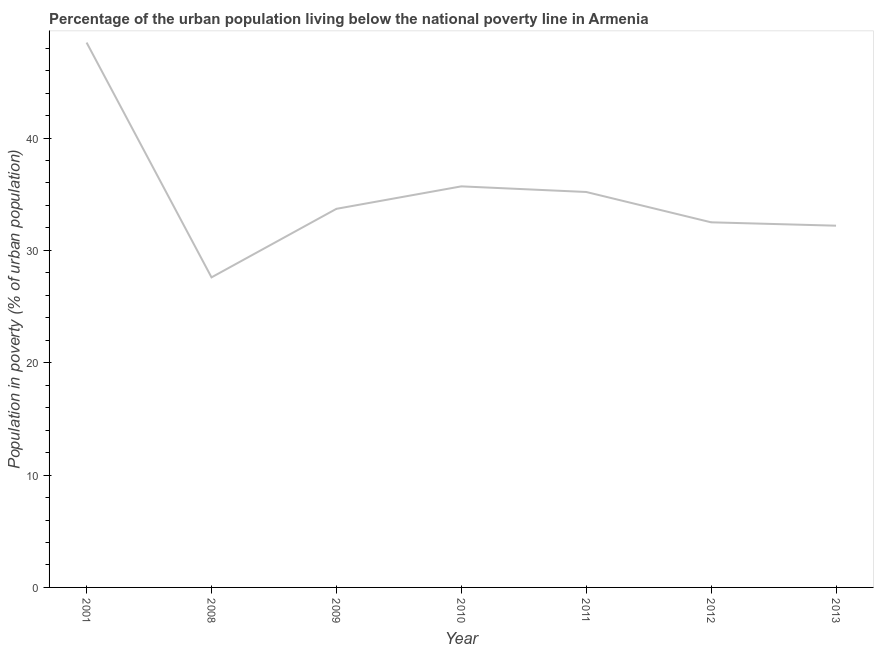What is the percentage of urban population living below poverty line in 2001?
Ensure brevity in your answer.  48.5. Across all years, what is the maximum percentage of urban population living below poverty line?
Keep it short and to the point. 48.5. Across all years, what is the minimum percentage of urban population living below poverty line?
Ensure brevity in your answer.  27.6. In which year was the percentage of urban population living below poverty line maximum?
Provide a succinct answer. 2001. In which year was the percentage of urban population living below poverty line minimum?
Offer a terse response. 2008. What is the sum of the percentage of urban population living below poverty line?
Provide a short and direct response. 245.4. What is the difference between the percentage of urban population living below poverty line in 2008 and 2009?
Give a very brief answer. -6.1. What is the average percentage of urban population living below poverty line per year?
Ensure brevity in your answer.  35.06. What is the median percentage of urban population living below poverty line?
Keep it short and to the point. 33.7. In how many years, is the percentage of urban population living below poverty line greater than 10 %?
Offer a very short reply. 7. Do a majority of the years between 2010 and 2011 (inclusive) have percentage of urban population living below poverty line greater than 6 %?
Your answer should be compact. Yes. What is the ratio of the percentage of urban population living below poverty line in 2010 to that in 2011?
Your response must be concise. 1.01. Is the percentage of urban population living below poverty line in 2011 less than that in 2013?
Make the answer very short. No. Is the difference between the percentage of urban population living below poverty line in 2009 and 2011 greater than the difference between any two years?
Your answer should be very brief. No. What is the difference between the highest and the second highest percentage of urban population living below poverty line?
Ensure brevity in your answer.  12.8. Is the sum of the percentage of urban population living below poverty line in 2008 and 2013 greater than the maximum percentage of urban population living below poverty line across all years?
Provide a short and direct response. Yes. What is the difference between the highest and the lowest percentage of urban population living below poverty line?
Provide a succinct answer. 20.9. In how many years, is the percentage of urban population living below poverty line greater than the average percentage of urban population living below poverty line taken over all years?
Offer a terse response. 3. How many years are there in the graph?
Ensure brevity in your answer.  7. Are the values on the major ticks of Y-axis written in scientific E-notation?
Make the answer very short. No. Does the graph contain grids?
Provide a succinct answer. No. What is the title of the graph?
Ensure brevity in your answer.  Percentage of the urban population living below the national poverty line in Armenia. What is the label or title of the Y-axis?
Keep it short and to the point. Population in poverty (% of urban population). What is the Population in poverty (% of urban population) in 2001?
Your response must be concise. 48.5. What is the Population in poverty (% of urban population) in 2008?
Give a very brief answer. 27.6. What is the Population in poverty (% of urban population) of 2009?
Keep it short and to the point. 33.7. What is the Population in poverty (% of urban population) in 2010?
Give a very brief answer. 35.7. What is the Population in poverty (% of urban population) in 2011?
Your response must be concise. 35.2. What is the Population in poverty (% of urban population) in 2012?
Offer a very short reply. 32.5. What is the Population in poverty (% of urban population) of 2013?
Give a very brief answer. 32.2. What is the difference between the Population in poverty (% of urban population) in 2001 and 2008?
Give a very brief answer. 20.9. What is the difference between the Population in poverty (% of urban population) in 2001 and 2009?
Offer a very short reply. 14.8. What is the difference between the Population in poverty (% of urban population) in 2001 and 2010?
Provide a short and direct response. 12.8. What is the difference between the Population in poverty (% of urban population) in 2001 and 2011?
Offer a terse response. 13.3. What is the difference between the Population in poverty (% of urban population) in 2008 and 2009?
Keep it short and to the point. -6.1. What is the difference between the Population in poverty (% of urban population) in 2008 and 2010?
Make the answer very short. -8.1. What is the difference between the Population in poverty (% of urban population) in 2009 and 2011?
Your response must be concise. -1.5. What is the difference between the Population in poverty (% of urban population) in 2009 and 2012?
Your response must be concise. 1.2. What is the difference between the Population in poverty (% of urban population) in 2009 and 2013?
Provide a succinct answer. 1.5. What is the difference between the Population in poverty (% of urban population) in 2010 and 2012?
Your answer should be compact. 3.2. What is the difference between the Population in poverty (% of urban population) in 2011 and 2013?
Offer a very short reply. 3. What is the ratio of the Population in poverty (% of urban population) in 2001 to that in 2008?
Your response must be concise. 1.76. What is the ratio of the Population in poverty (% of urban population) in 2001 to that in 2009?
Ensure brevity in your answer.  1.44. What is the ratio of the Population in poverty (% of urban population) in 2001 to that in 2010?
Your answer should be very brief. 1.36. What is the ratio of the Population in poverty (% of urban population) in 2001 to that in 2011?
Your response must be concise. 1.38. What is the ratio of the Population in poverty (% of urban population) in 2001 to that in 2012?
Offer a terse response. 1.49. What is the ratio of the Population in poverty (% of urban population) in 2001 to that in 2013?
Provide a succinct answer. 1.51. What is the ratio of the Population in poverty (% of urban population) in 2008 to that in 2009?
Offer a terse response. 0.82. What is the ratio of the Population in poverty (% of urban population) in 2008 to that in 2010?
Give a very brief answer. 0.77. What is the ratio of the Population in poverty (% of urban population) in 2008 to that in 2011?
Make the answer very short. 0.78. What is the ratio of the Population in poverty (% of urban population) in 2008 to that in 2012?
Offer a very short reply. 0.85. What is the ratio of the Population in poverty (% of urban population) in 2008 to that in 2013?
Give a very brief answer. 0.86. What is the ratio of the Population in poverty (% of urban population) in 2009 to that in 2010?
Keep it short and to the point. 0.94. What is the ratio of the Population in poverty (% of urban population) in 2009 to that in 2011?
Keep it short and to the point. 0.96. What is the ratio of the Population in poverty (% of urban population) in 2009 to that in 2013?
Your response must be concise. 1.05. What is the ratio of the Population in poverty (% of urban population) in 2010 to that in 2011?
Offer a very short reply. 1.01. What is the ratio of the Population in poverty (% of urban population) in 2010 to that in 2012?
Give a very brief answer. 1.1. What is the ratio of the Population in poverty (% of urban population) in 2010 to that in 2013?
Provide a short and direct response. 1.11. What is the ratio of the Population in poverty (% of urban population) in 2011 to that in 2012?
Your answer should be very brief. 1.08. What is the ratio of the Population in poverty (% of urban population) in 2011 to that in 2013?
Provide a succinct answer. 1.09. 